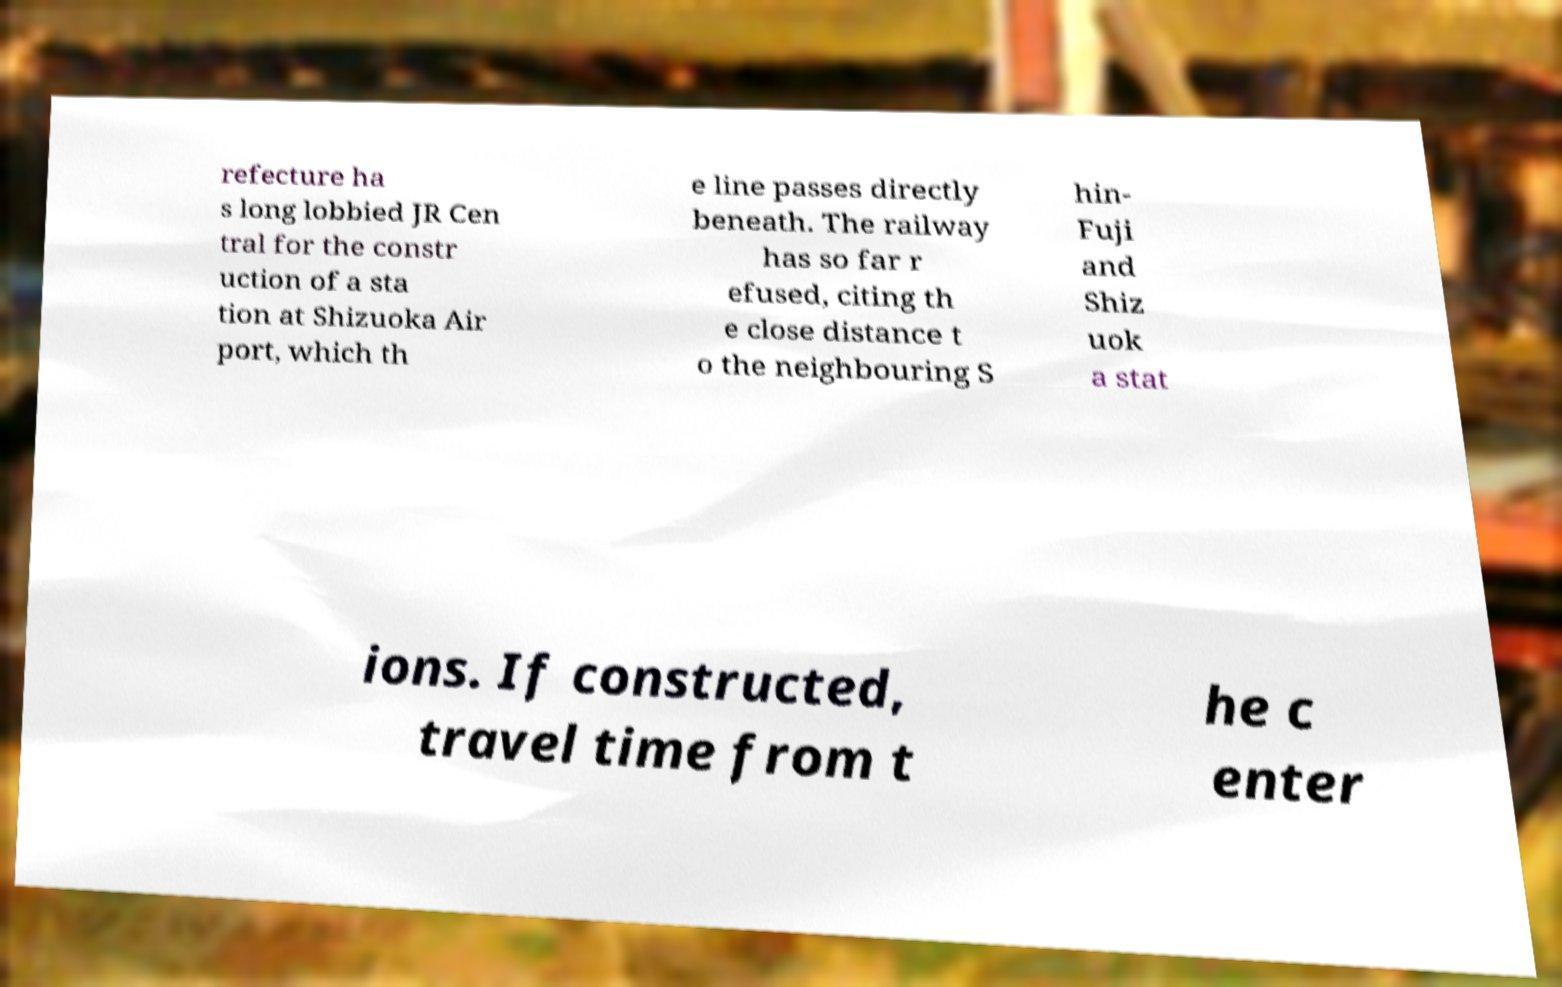Could you extract and type out the text from this image? refecture ha s long lobbied JR Cen tral for the constr uction of a sta tion at Shizuoka Air port, which th e line passes directly beneath. The railway has so far r efused, citing th e close distance t o the neighbouring S hin- Fuji and Shiz uok a stat ions. If constructed, travel time from t he c enter 